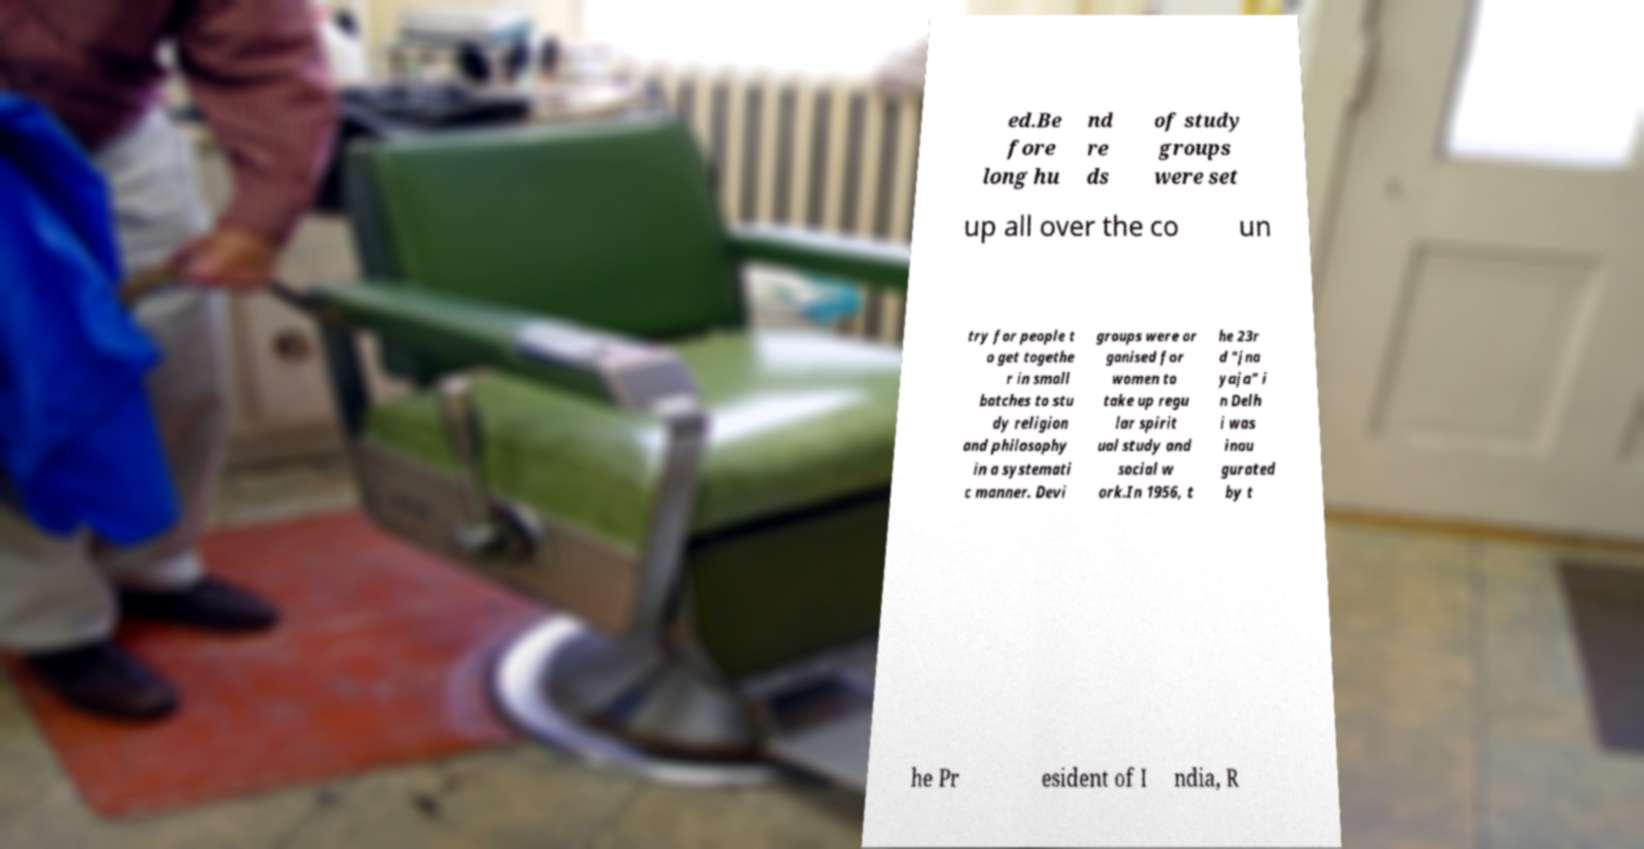What messages or text are displayed in this image? I need them in a readable, typed format. ed.Be fore long hu nd re ds of study groups were set up all over the co un try for people t o get togethe r in small batches to stu dy religion and philosophy in a systemati c manner. Devi groups were or ganised for women to take up regu lar spirit ual study and social w ork.In 1956, t he 23r d "jna yaja" i n Delh i was inau gurated by t he Pr esident of I ndia, R 